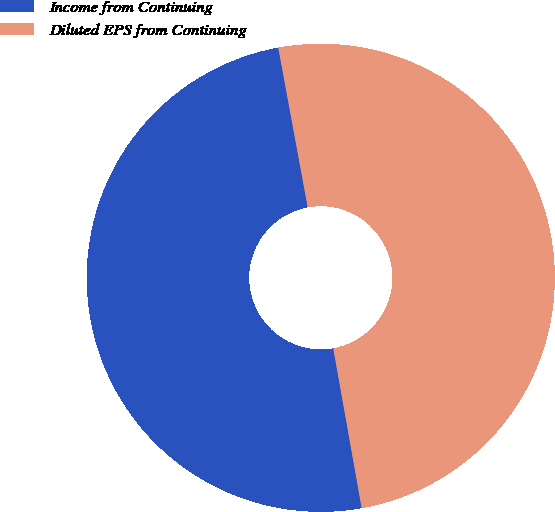<chart> <loc_0><loc_0><loc_500><loc_500><pie_chart><fcel>Income from Continuing<fcel>Diluted EPS from Continuing<nl><fcel>49.9%<fcel>50.1%<nl></chart> 